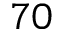Convert formula to latex. <formula><loc_0><loc_0><loc_500><loc_500>7 0</formula> 